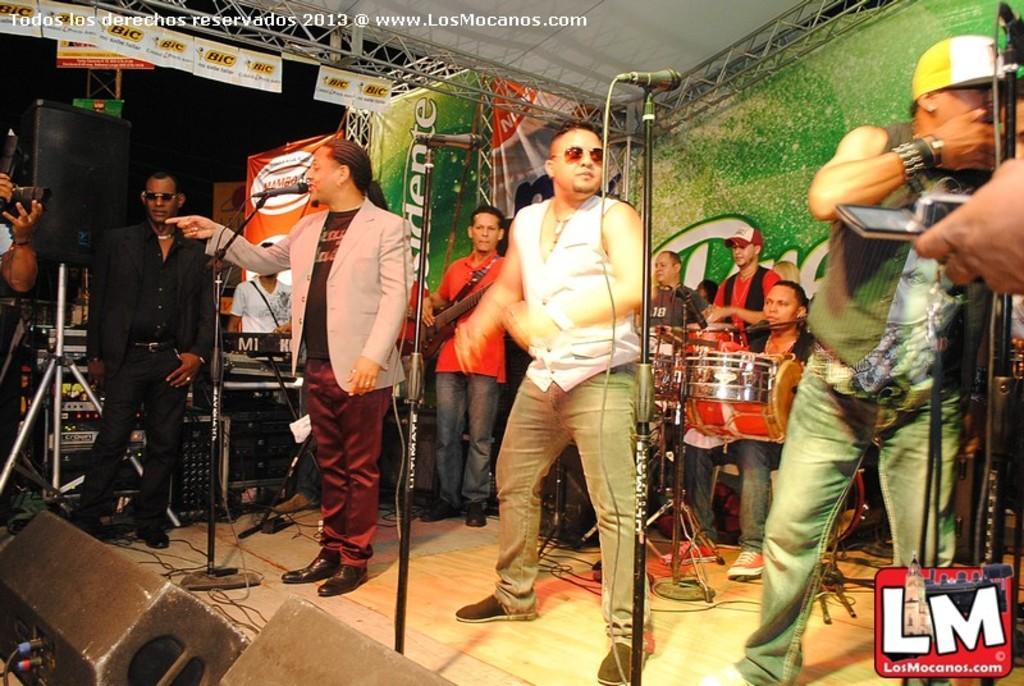Can you describe this image briefly? In this image In the middle there is a man he wears t shirt, suit, trouser and shoes. he is singing. On the right there is a man he wears t shirt, trouser and cap he is speaking some thing. On the left there is a man he wear shirt and trouser he is standing. In the background there are some people, drums, keyboard and some musical instruments. 